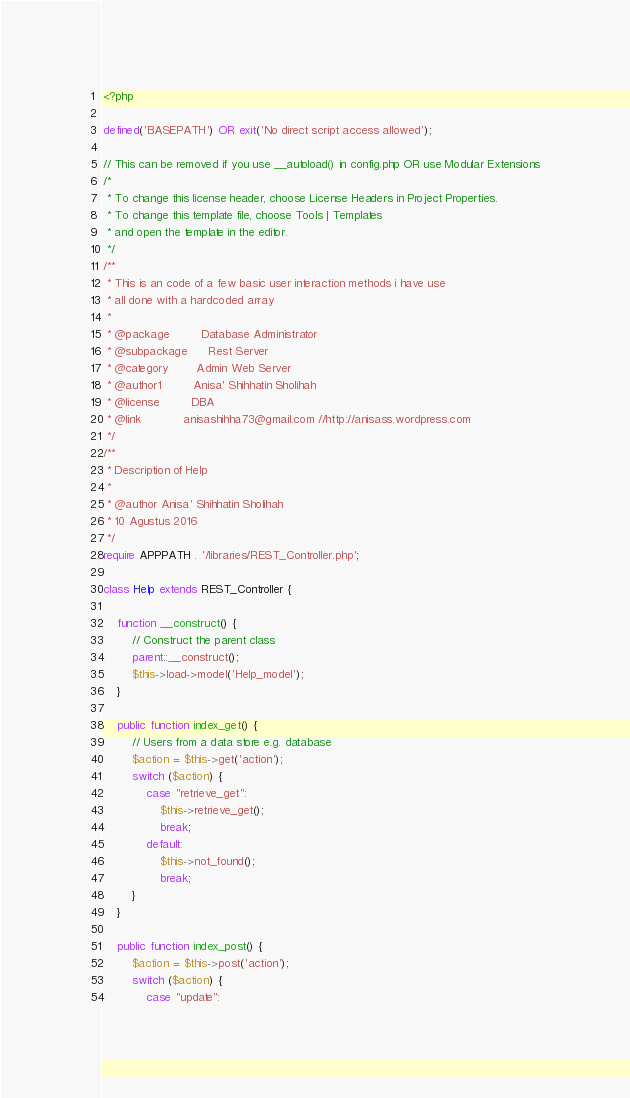<code> <loc_0><loc_0><loc_500><loc_500><_PHP_><?php

defined('BASEPATH') OR exit('No direct script access allowed');

// This can be removed if you use __autoload() in config.php OR use Modular Extensions
/*
 * To change this license header, choose License Headers in Project Properties.
 * To change this template file, choose Tools | Templates
 * and open the template in the editor.
 */
/**
 * This is an code of a few basic user interaction methods i have use
 * all done with a hardcoded array
 *
 * @package         Database Administrator
 * @subpackage      Rest Server
 * @category        Admin Web Server
 * @author1         Anisa' Shihhatin Sholihah
 * @license         DBA
 * @link            anisashihha73@gmail.com //http://anisass.wordpress.com
 */
/**
 * Description of Help
 *
 * @author Anisa' Shihhatin Sholihah 
 * 10 Agustus 2016
 */
require APPPATH . '/libraries/REST_Controller.php';

class Help extends REST_Controller {

    function __construct() {
        // Construct the parent class
        parent::__construct();
        $this->load->model('Help_model');
    }

    public function index_get() {
        // Users from a data store e.g. database
        $action = $this->get('action');
        switch ($action) {
            case "retrieve_get":
                $this->retrieve_get();
                break;
            default:
                $this->not_found();
                break;
        }
    }

    public function index_post() {
        $action = $this->post('action');
        switch ($action) {
            case "update":</code> 